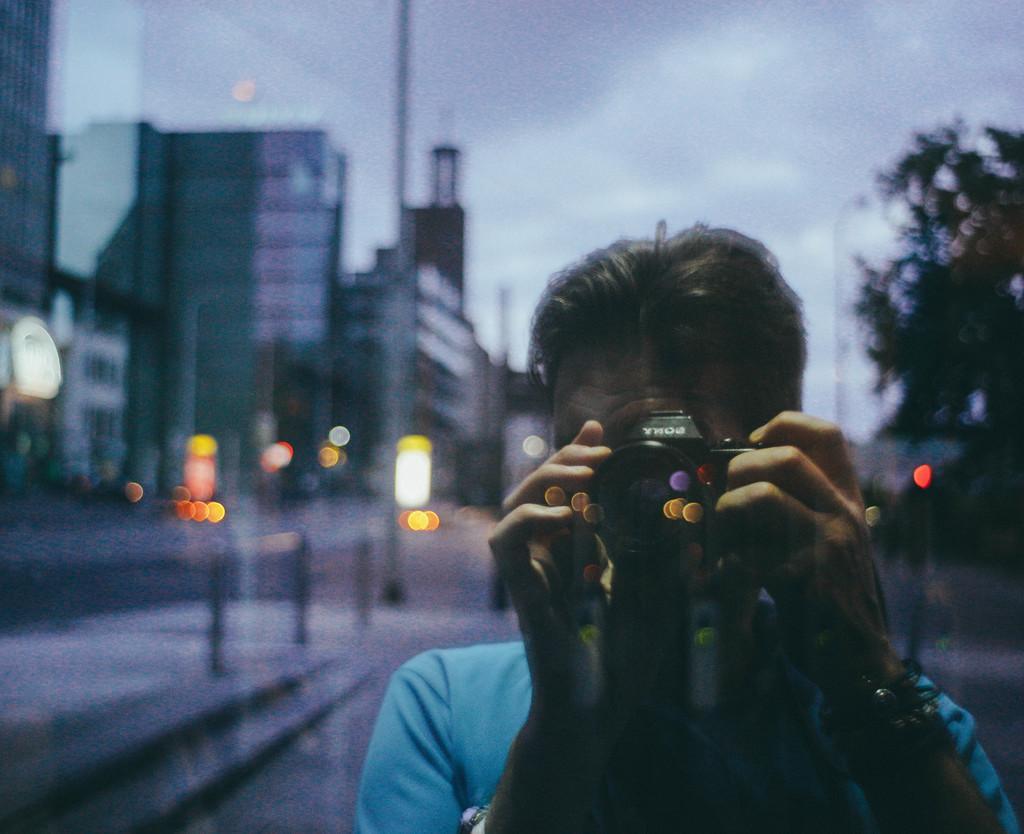Describe this image in one or two sentences. In this image there is a person standing and holding a camera in his hand. The background is blurry. 